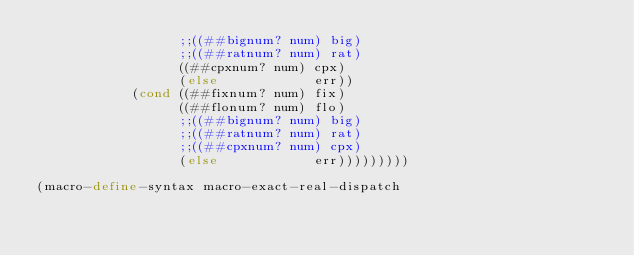Convert code to text. <code><loc_0><loc_0><loc_500><loc_500><_Scheme_>                  ;;((##bignum? num) big)
                  ;;((##ratnum? num) rat)
                  ((##cpxnum? num) cpx)
                  (else            err))
            (cond ((##fixnum? num) fix)
                  ((##flonum? num) flo)
                  ;;((##bignum? num) big)
                  ;;((##ratnum? num) rat)
                  ;;((##cpxnum? num) cpx)
                  (else            err)))))))))

(macro-define-syntax macro-exact-real-dispatch</code> 